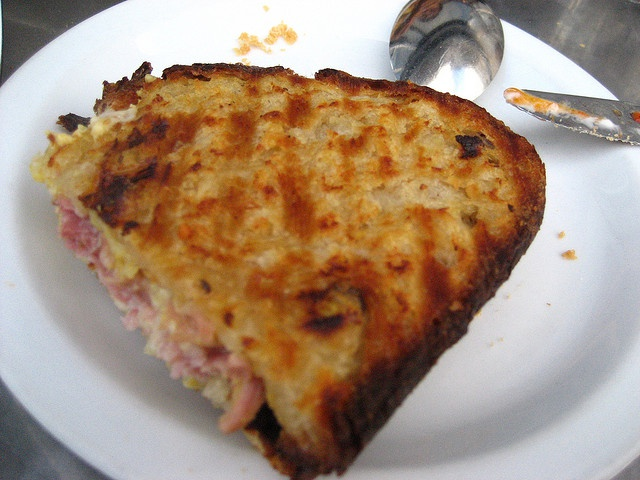Describe the objects in this image and their specific colors. I can see sandwich in darkgray, brown, maroon, tan, and gray tones, spoon in darkgray, gray, white, and black tones, and knife in darkgray, gray, tan, and lightgray tones in this image. 